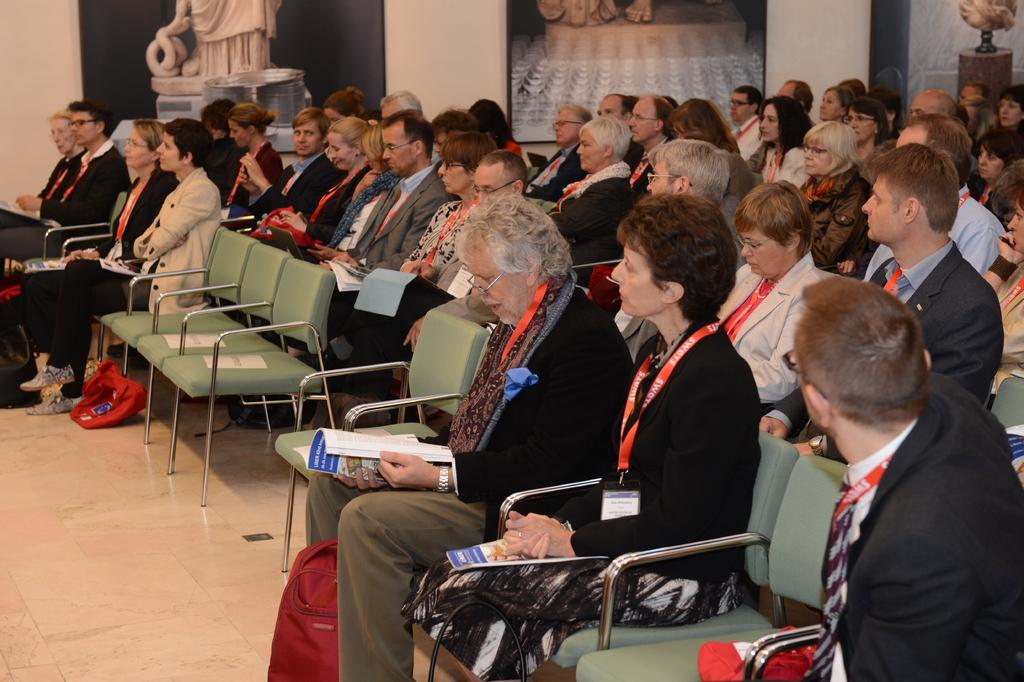Where is the woman located in the image? The woman is sitting on a chair on the right side of the image. What is the woman wearing in the image? The woman is wearing a black coat in the image. What is the old man doing in the image? The old man is looking at a book in the image. How many people are sitting on chairs in the image? There are other people sitting on chairs in the image, but the exact number is not specified. What type of metal is the woman using to smash the book in the image? There is no mention of the woman smashing a book or using any metal object in the image. 